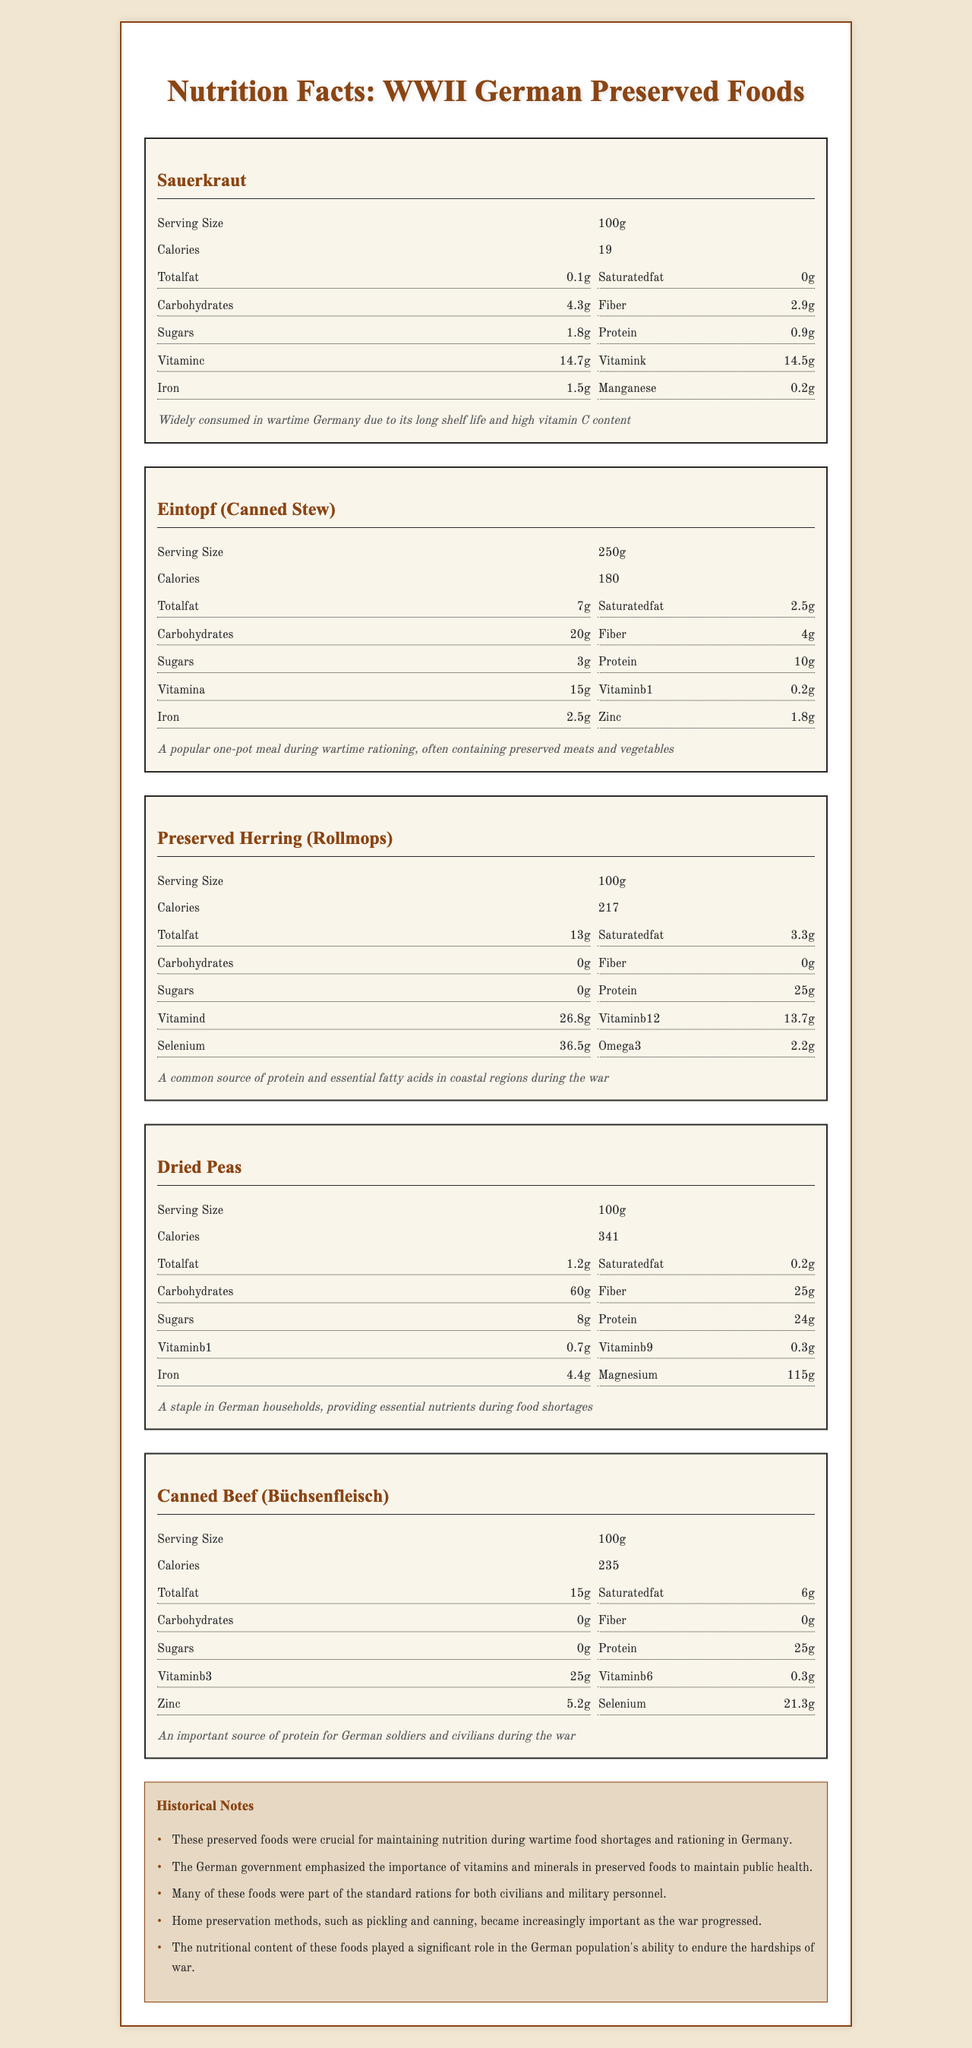what is the serving size of Sauerkraut? The serving size is indicated at the top of the Sauerkraut section.
Answer: 100g how many calories are there in Eintopf? The number of calories for each food item is displayed under the serving size, and it shows 180 calories for Eintopf.
Answer: 180 which nutrient is highest in preserved herring? The document lists the nutrients and their amounts for preserved herring; protein is the highest at 25g.
Answer: protein how much iron is there in dried peas? The amount of iron is listed in the nutrients section under dried peas, showing 4.4g.
Answer: 4.4g what is the historical context for canned beef (Büchsenfleisch)? Each food item includes a historical context at the end of its section.
Answer: An important source of protein for German soldiers and civilians during the war which food has the highest fiber content? A. Sauerkraut B. Eintopf C. Dried Peas D. Preserved Herring The fiber content is highest in dried peas at 25g, compared to the other options which have lower fiber content.
Answer: C which preserved food is a common source of protein and essential fatty acids in coastal regions during WWII? 1. Sauerkraut 2. Eintopf 3. Preserved Herring 4. Canned Beef (Büchsenfleisch) The historical context for preserved herring mentions it was a common source of protein and essential fatty acids in coastal regions.
Answer: 3 does any of the preserved foods listed contain vitamin C? Both Sauerkraut and Sauerkraut contain vitamin C as listed in their nutrient facts.
Answer: Yes summarize the main idea of the document The main idea of the document involves detailed nutritional content and historical importance of various preserved foods that were crucial for the German population during WWII.
Answer: The document provides nutritional information and historical context for several preserved foods common in WWII-era German households. These foods, including Sauerkraut, Eintopf, preserved herring, dried peas, and canned beef, were important for maintaining nutrition during wartime shortages and rationing. The document also includes historical notes emphasizing the significance of vitamins and minerals in these foods for public health during the war. which nutrient content in Sauerkraut supports its use for combating scurvy during WWII? Sauerkraut has 14.7g of vitamin C, which is essential for preventing scurvy, a disease caused by vitamin C deficiency.
Answer: vitamin C how many calories are in 200g of dried peas? The document only provides nutritional information for a serving size of 100g; it does not provide information for 200g directly.
Answer: Cannot be determined 